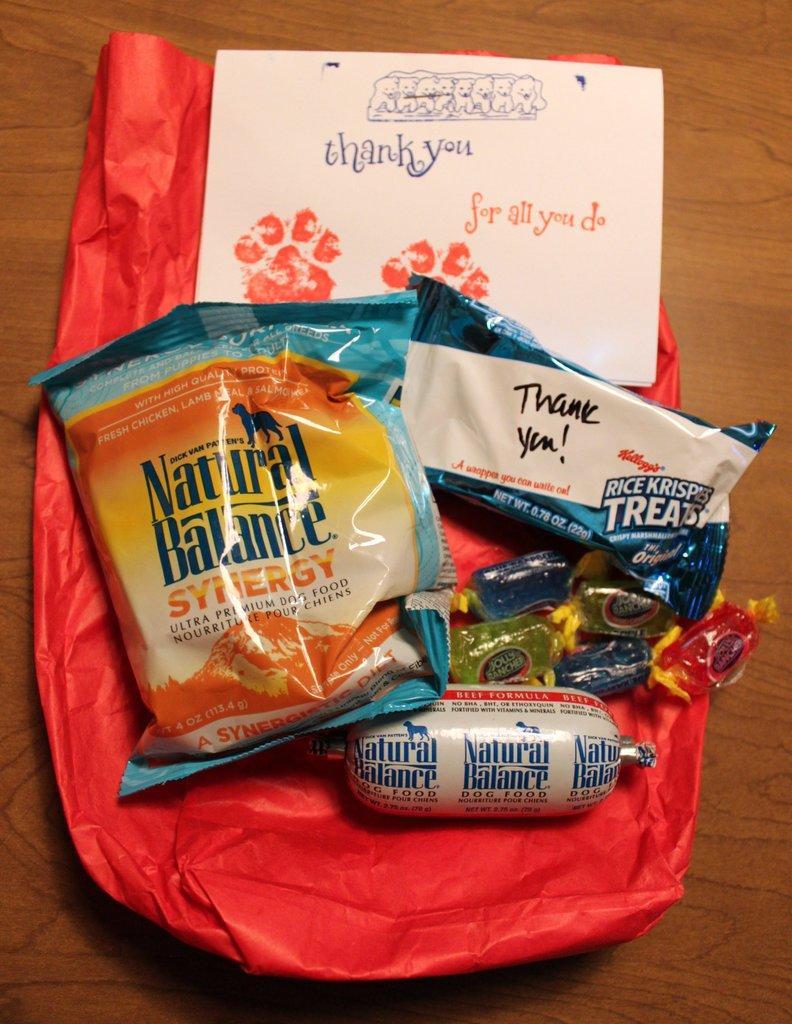In one or two sentences, can you explain what this image depicts? In this image we can see few candies, packets and a paper with text and design on the table. 